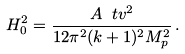<formula> <loc_0><loc_0><loc_500><loc_500>H _ { 0 } ^ { 2 } = \frac { A \ t v ^ { 2 } } { 1 2 \pi ^ { 2 } ( k + 1 ) ^ { 2 } M _ { p } ^ { 2 } } \, .</formula> 